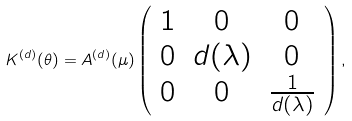<formula> <loc_0><loc_0><loc_500><loc_500>K ^ { ( d ) } ( \theta ) = A ^ { ( d ) } ( \mu ) \left ( \begin{array} { c c c } 1 & 0 & 0 \\ 0 & d ( \lambda ) & 0 \\ 0 & 0 & \frac { 1 } { d ( \lambda ) } \end{array} \right ) ,</formula> 